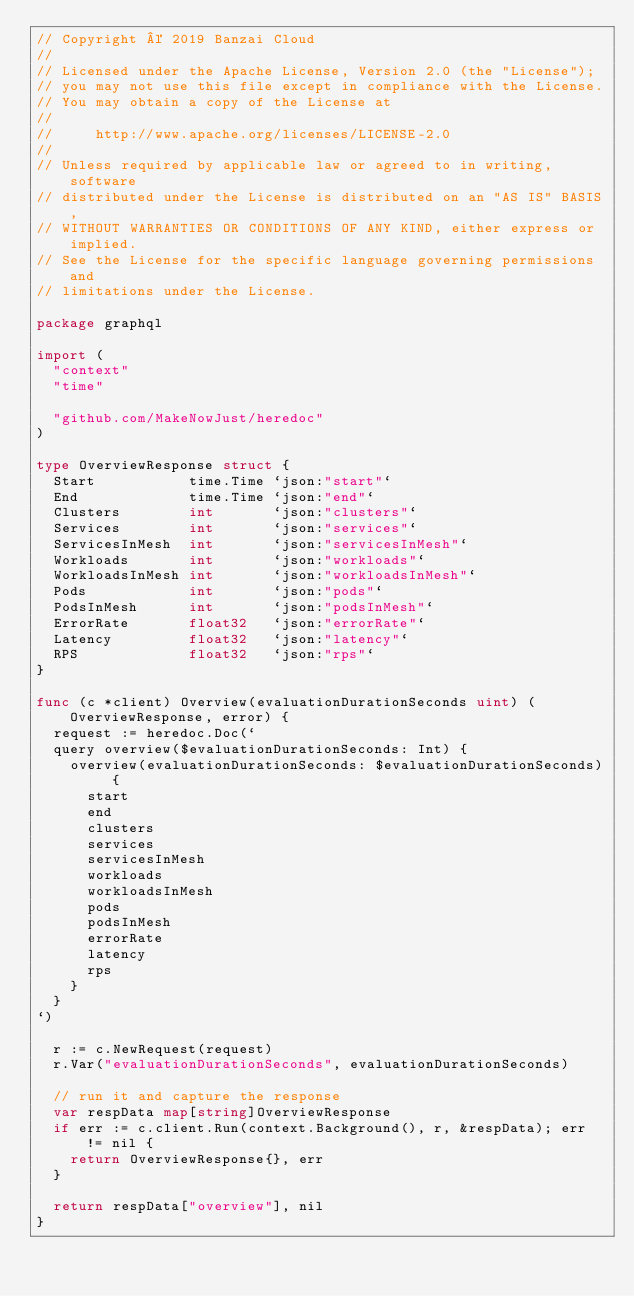Convert code to text. <code><loc_0><loc_0><loc_500><loc_500><_Go_>// Copyright © 2019 Banzai Cloud
//
// Licensed under the Apache License, Version 2.0 (the "License");
// you may not use this file except in compliance with the License.
// You may obtain a copy of the License at
//
//     http://www.apache.org/licenses/LICENSE-2.0
//
// Unless required by applicable law or agreed to in writing, software
// distributed under the License is distributed on an "AS IS" BASIS,
// WITHOUT WARRANTIES OR CONDITIONS OF ANY KIND, either express or implied.
// See the License for the specific language governing permissions and
// limitations under the License.

package graphql

import (
	"context"
	"time"

	"github.com/MakeNowJust/heredoc"
)

type OverviewResponse struct {
	Start           time.Time `json:"start"`
	End             time.Time `json:"end"`
	Clusters        int       `json:"clusters"`
	Services        int       `json:"services"`
	ServicesInMesh  int       `json:"servicesInMesh"`
	Workloads       int       `json:"workloads"`
	WorkloadsInMesh int       `json:"workloadsInMesh"`
	Pods            int       `json:"pods"`
	PodsInMesh      int       `json:"podsInMesh"`
	ErrorRate       float32   `json:"errorRate"`
	Latency         float32   `json:"latency"`
	RPS             float32   `json:"rps"`
}

func (c *client) Overview(evaluationDurationSeconds uint) (OverviewResponse, error) {
	request := heredoc.Doc(`
	query overview($evaluationDurationSeconds: Int) {
		overview(evaluationDurationSeconds: $evaluationDurationSeconds) {
			start
			end
			clusters
			services
			servicesInMesh
			workloads
			workloadsInMesh
			pods
			podsInMesh
			errorRate
			latency
			rps
		}
	}
`)

	r := c.NewRequest(request)
	r.Var("evaluationDurationSeconds", evaluationDurationSeconds)

	// run it and capture the response
	var respData map[string]OverviewResponse
	if err := c.client.Run(context.Background(), r, &respData); err != nil {
		return OverviewResponse{}, err
	}

	return respData["overview"], nil
}
</code> 